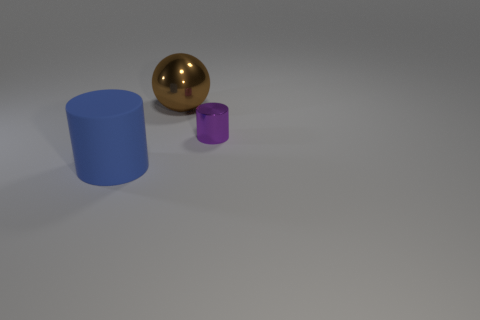Do the small purple thing and the blue cylinder have the same material? The materials look different. The small purple object appears to have a matte surface, while the blue cylinder has a smooth, slightly reflective finish, indicating they are made from different materials. 